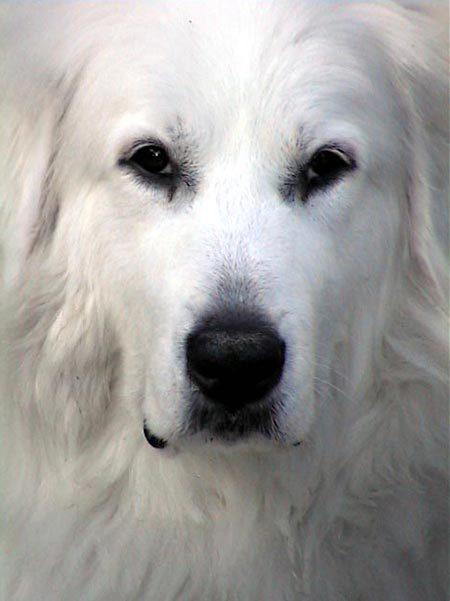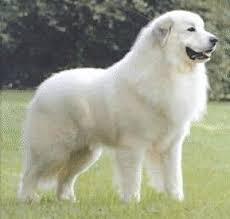The first image is the image on the left, the second image is the image on the right. Evaluate the accuracy of this statement regarding the images: "Dogs are sticking out their tongues far enough for the tongues to be visible.". Is it true? Answer yes or no. No. 